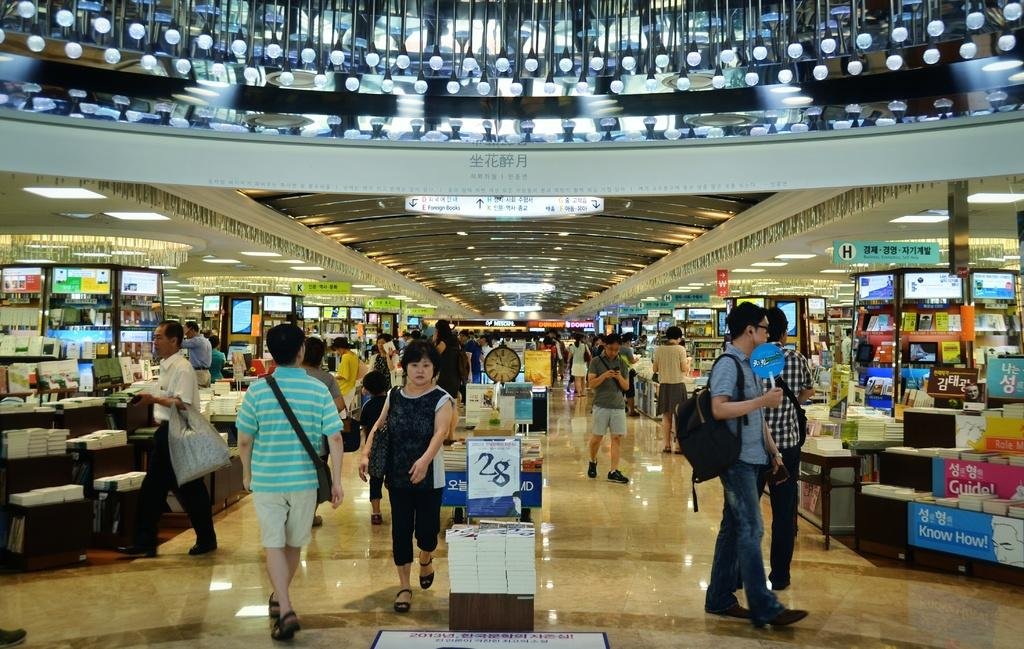Provide a one-sentence caption for the provided image. Foreign books can be found in section E. 